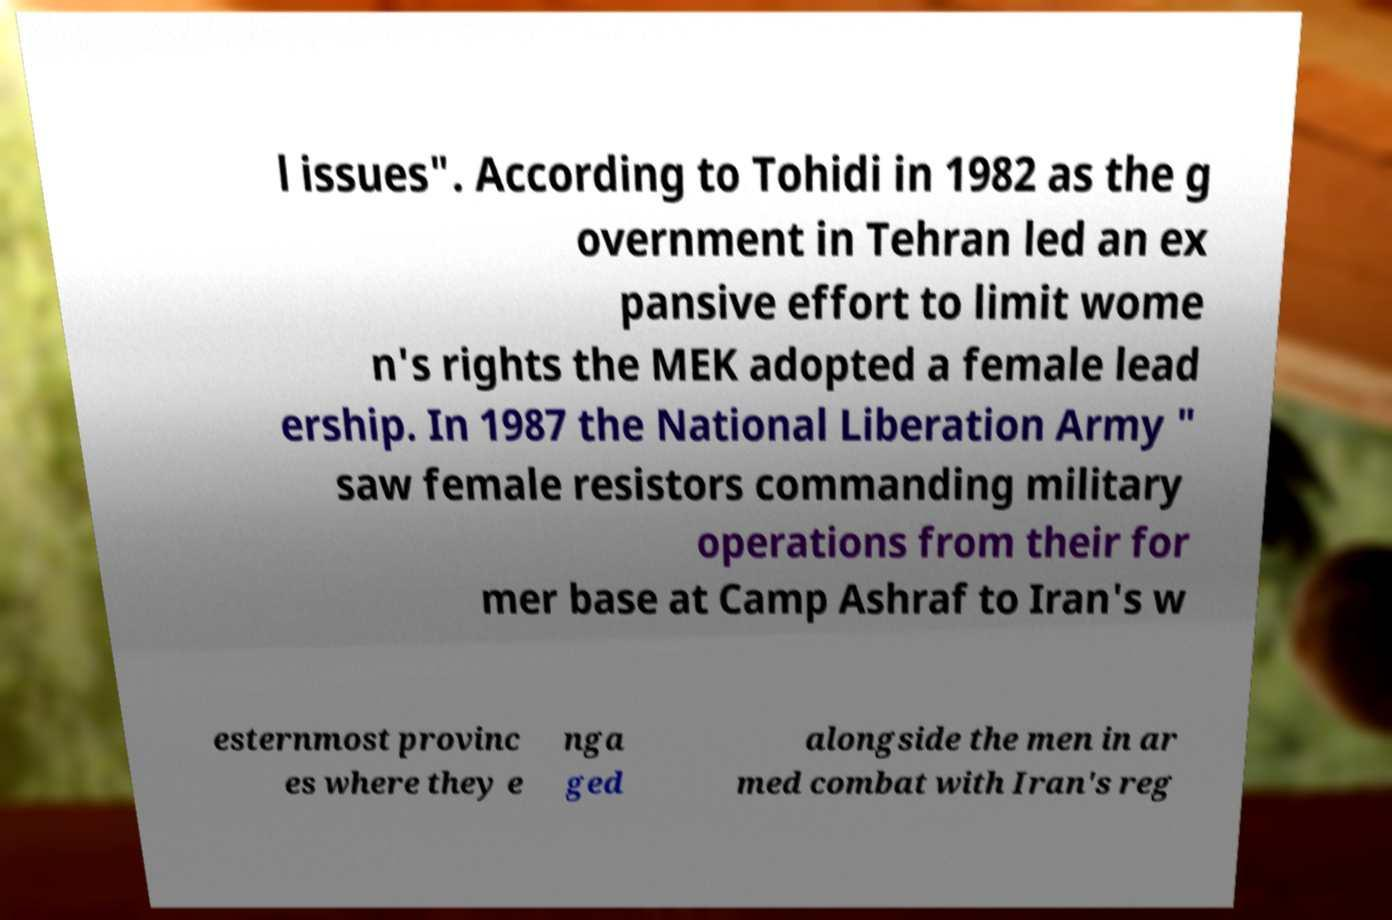Could you assist in decoding the text presented in this image and type it out clearly? l issues". According to Tohidi in 1982 as the g overnment in Tehran led an ex pansive effort to limit wome n's rights the MEK adopted a female lead ership. In 1987 the National Liberation Army " saw female resistors commanding military operations from their for mer base at Camp Ashraf to Iran's w esternmost provinc es where they e nga ged alongside the men in ar med combat with Iran's reg 